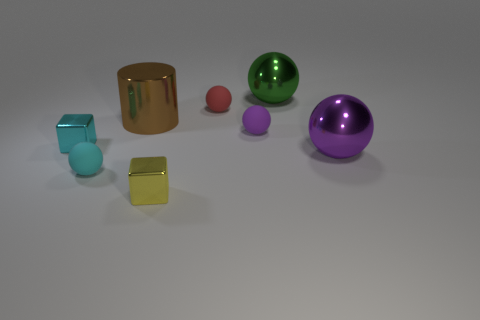Are there the same number of small red rubber balls on the left side of the purple matte object and spheres?
Ensure brevity in your answer.  No. Is there anything else that is the same material as the large brown cylinder?
Your response must be concise. Yes. How many small objects are purple cylinders or cyan objects?
Ensure brevity in your answer.  2. Does the cube right of the brown shiny thing have the same material as the big brown object?
Ensure brevity in your answer.  Yes. What material is the tiny cyan thing that is behind the big thing in front of the purple matte thing made of?
Provide a succinct answer. Metal. What number of other tiny rubber things are the same shape as the red rubber thing?
Provide a short and direct response. 2. There is a rubber ball in front of the purple object behind the metallic object that is right of the large green shiny sphere; what size is it?
Make the answer very short. Small. What number of blue things are either tiny matte spheres or big shiny balls?
Make the answer very short. 0. There is a small cyan object behind the large purple object; does it have the same shape as the small red rubber object?
Give a very brief answer. No. Are there more red rubber objects that are to the right of the tiny cyan matte object than green metallic things?
Your answer should be compact. No. 